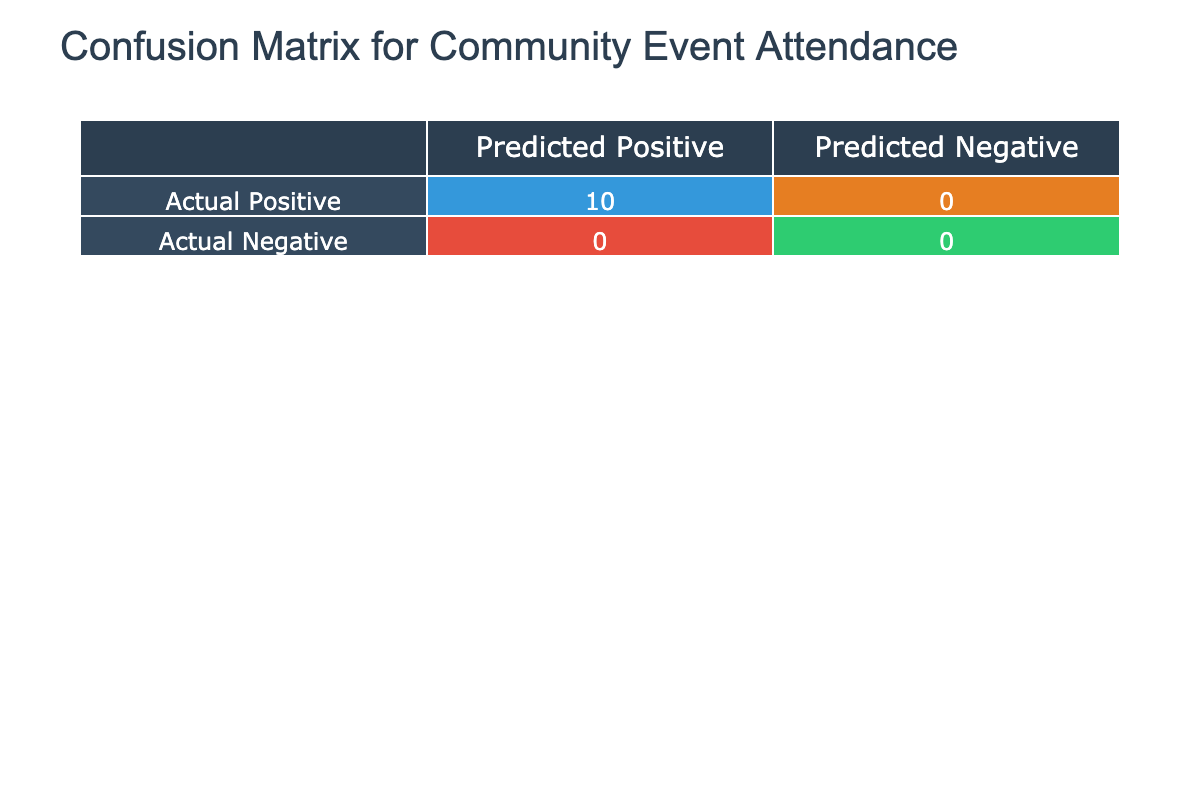What is the number of true positives in the confusion matrix? True positives are counted as instances where both predicted and actual attendance are positive. In the table, predicted attendance is considered positive for values greater than or equal to zero. Here, the confusion matrix indicates there are 5 events (Community Potluck, Local Music Festival, Charity Run, Farmers Market, and School Fundraiser) where both predicted and actual attendance meet or exceed zero.
Answer: 5 How many events had an actual attendance that exceeded the predicted attendance? To find the number of events where actual attendance exceeded predicted attendance, compare each pair from both columns. The events that satisfy this condition are Neighborhood Clean-up, Art Exhibition, School Fundraiser, and Town Hall Meeting, amounting to a total of 4 events.
Answer: 4 What is the total number of false negatives in the confusion matrix? False negatives occur when actual attendance is positive but predicted attendance is not. From our data, only one event shows this situation: Book Club Meeting. Therefore, the total number of false negatives is 1.
Answer: 1 Is there any event where the predicted attendance perfectly matched the actual attendance? To determine if there’s a match, we need to identify events where the predicted and actual attendance figures are the same. The only event that perfectly matches is the Charity Run. Thus, there is one such event.
Answer: Yes What is the average predicted attendance for events that had positive actual attendance? First, we identify events with positive actual attendance, which are Community Potluck, Neighborhood Clean-up, Local Music Festival, Charity Run, Farmers Market, Outdoor Movie Night, and School Fundraiser. The predicted attendance for these events sums up to 100 + 50 + 200 + 150 + 300 + 80 + 120 = 1000. There are 7 events, so the average predicted attendance is 1000/7 ≈ 142.86.
Answer: 142.86 Which event had the most significant discrepancy between predicted and actual attendance? Discrepancy is determined by the absolute difference between predicted and actual attendance. By calculating these differences: Community Potluck (10), Neighborhood Clean-up (15), Local Music Festival (20), Charity Run (0), Book Club Meeting (5), Art Exhibition (15), Farmers Market (20), Outdoor Movie Night (10), School Fundraiser (20), and Town Hall Meeting (10). The maximum discrepancy is 20, which affects three events: Local Music Festival, Farmers Market, and School Fundraiser.
Answer: Local Music Festival, Farmers Market, and School Fundraiser How many events were predicted to have an attendance of 100 or more, but had an actual attendance of less than 100? From the data, the events that meet this criterion are Neighborhood Clean-up (predicted 50, actual 65) - not counted; the predicted artworks because they all had actual attendance of over 100. Only Outdoor Movie Night stands out with predicted 80, actual 70, which counts. Therefore, the count is 1.
Answer: 1 What percentage of events had accurately predicted attendance compared to actual attendance (right predictions)? Correct predictions are the same as true positives, which we've established are 5. The total number of events is 10. Therefore, the percentage of correctly predicted events is (5/10) * 100 = 50%.
Answer: 50% 